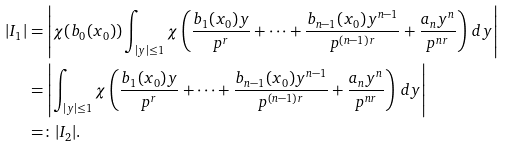<formula> <loc_0><loc_0><loc_500><loc_500>| I _ { 1 } | & = \left | \chi ( b _ { 0 } ( x _ { 0 } ) ) \int _ { | y | \leq 1 } \chi \left ( \frac { b _ { 1 } ( x _ { 0 } ) y } { p ^ { r } } + \dots + \frac { b _ { n - 1 } ( x _ { 0 } ) y ^ { n - 1 } } { p ^ { ( n - 1 ) r } } + \frac { a _ { n } y ^ { n } } { p ^ { n r } } \right ) \, d y \right | \\ & = \left | \int _ { | y | \leq 1 } \chi \left ( \frac { b _ { 1 } ( x _ { 0 } ) y } { p ^ { r } } + \dots + \frac { b _ { n - 1 } ( x _ { 0 } ) y ^ { n - 1 } } { p ^ { ( n - 1 ) r } } + \frac { a _ { n } y ^ { n } } { p ^ { n r } } \right ) \, d y \right | \\ & = \colon | I _ { 2 } | .</formula> 